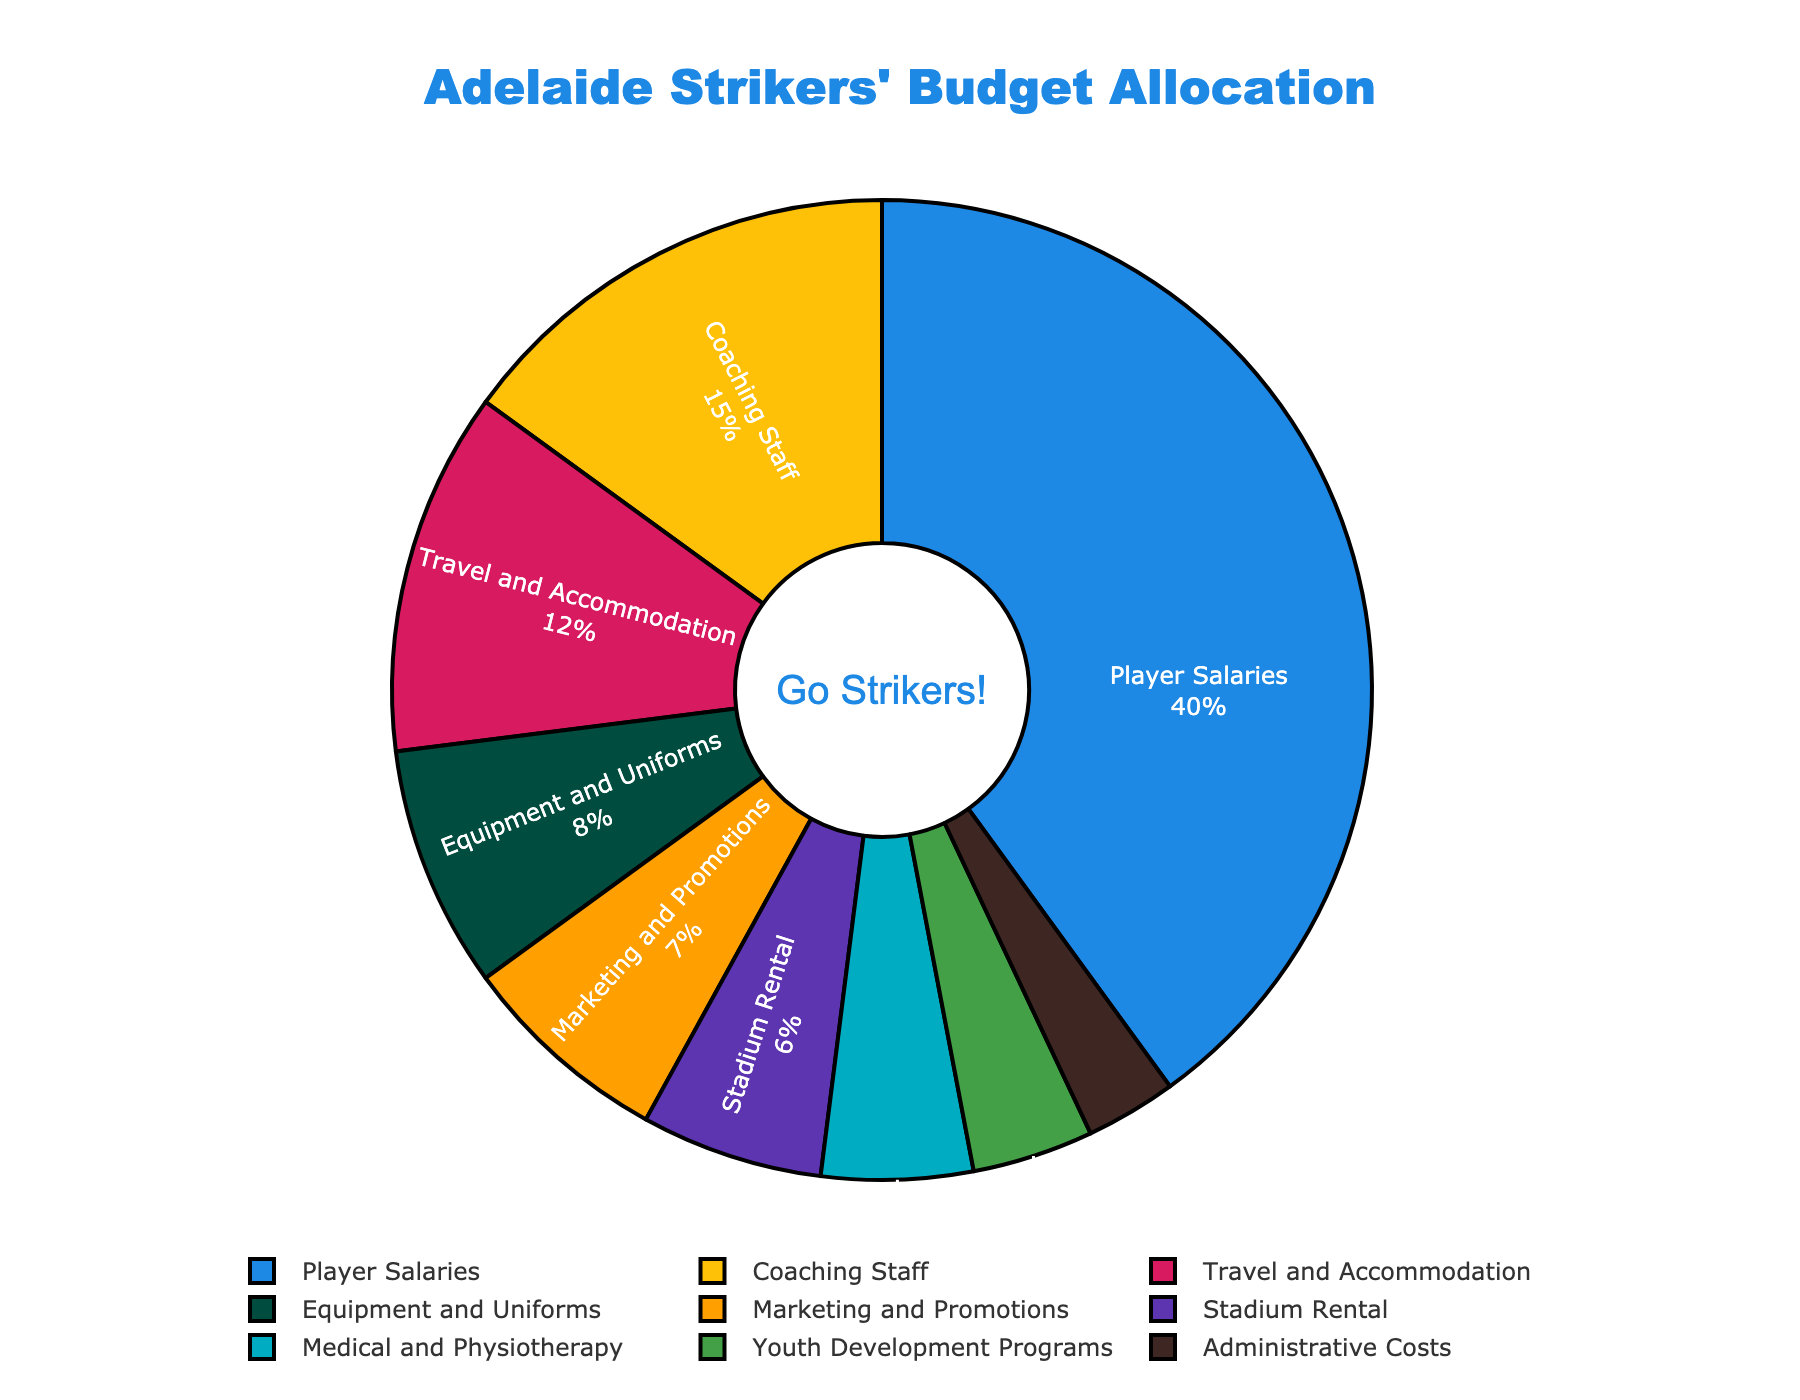What percentage of the total budget is allocated to Player Salaries? The pie chart shows that Player Salaries is allocated 40% of the total budget.
Answer: 40% Which category is allocated more budget: Coaching Staff or Medical and Physiotherapy? The pie chart shows Coaching Staff is allocated 15%, whereas Medical and Physiotherapy is allocated 5%. Therefore, Coaching Staff is allocated more budget.
Answer: Coaching Staff What is the combined percentage of the budget allocated to Travel and Accommodation, and Equipment and Uniforms? The pie chart shows Travel and Accommodation is 12% and Equipment and Uniforms is 8%. Adding them together gives 12% + 8% = 20%.
Answer: 20% Is the budget allocated to Youth Development Programs greater than the budget allocated to Administrative Costs? According to the pie chart, Youth Development Programs are allocated 4%, whereas Administrative Costs are allocated 3%. Therefore, Youth Development Programs are allocated more.
Answer: Yes Which expense category is allocated the least budget? From the pie chart, the least budget allocation is for Administrative Costs at 3%.
Answer: Administrative Costs How much more is allocated to Marketing and Promotions compared to Stadium Rental? The pie chart shows Marketing and Promotions is allocated 7%, whereas Stadium Rental is allocated 6%. The difference is 7% - 6% = 1%.
Answer: 1% What are the top three categories in terms of budget allocation? From the pie chart, the top three categories are: Player Salaries (40%), Coaching Staff (15%), and Travel and Accommodation (12%).
Answer: Player Salaries, Coaching Staff, Travel and Accommodation Adding the percentages for Medical and Physiotherapy, Youth Development Programs, and Administrative Costs, what fraction of the budget is allocated to these three categories combined? From the pie chart, Medical and Physiotherapy is 5%, Youth Development Programs is 4%, and Administrative Costs is 3%. Adding them together gives 5% + 4% + 3% = 12%.
Answer: 12% By what percentage does Player Salaries exceed the combined total of Coaching Staff and Equipment and Uniforms? The pie chart shows Player Salaries at 40%, Coaching Staff at 15%, and Equipment and Uniforms at 8%. The combined total of Coaching Staff and Equipment and Uniforms is 15% + 8% = 23%. The excess percentage is 40% - 23% = 17%.
Answer: 17% What is the combined percentage of the budget allocated to non-salary expenses? The salary-related categories are Player Salaries (40%) and Coaching Staff (15%). Their combined percentage is 40% + 15% = 55%. Thus, the non-salary expenses are the remaining percentage: 100% - 55% = 45%.
Answer: 45% 